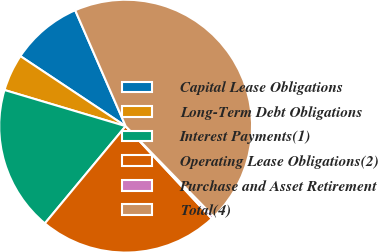Convert chart. <chart><loc_0><loc_0><loc_500><loc_500><pie_chart><fcel>Capital Lease Obligations<fcel>Long-Term Debt Obligations<fcel>Interest Payments(1)<fcel>Operating Lease Obligations(2)<fcel>Purchase and Asset Retirement<fcel>Total(4)<nl><fcel>9.12%<fcel>4.73%<fcel>18.58%<fcel>22.97%<fcel>0.34%<fcel>44.25%<nl></chart> 